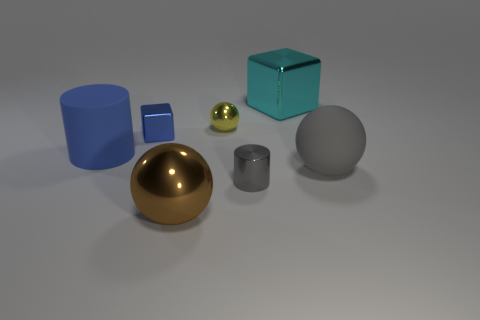Add 3 large cubes. How many objects exist? 10 Subtract all balls. How many objects are left? 4 Subtract 0 purple cubes. How many objects are left? 7 Subtract all large gray matte things. Subtract all large red metallic balls. How many objects are left? 6 Add 6 rubber cylinders. How many rubber cylinders are left? 7 Add 4 big cyan cubes. How many big cyan cubes exist? 5 